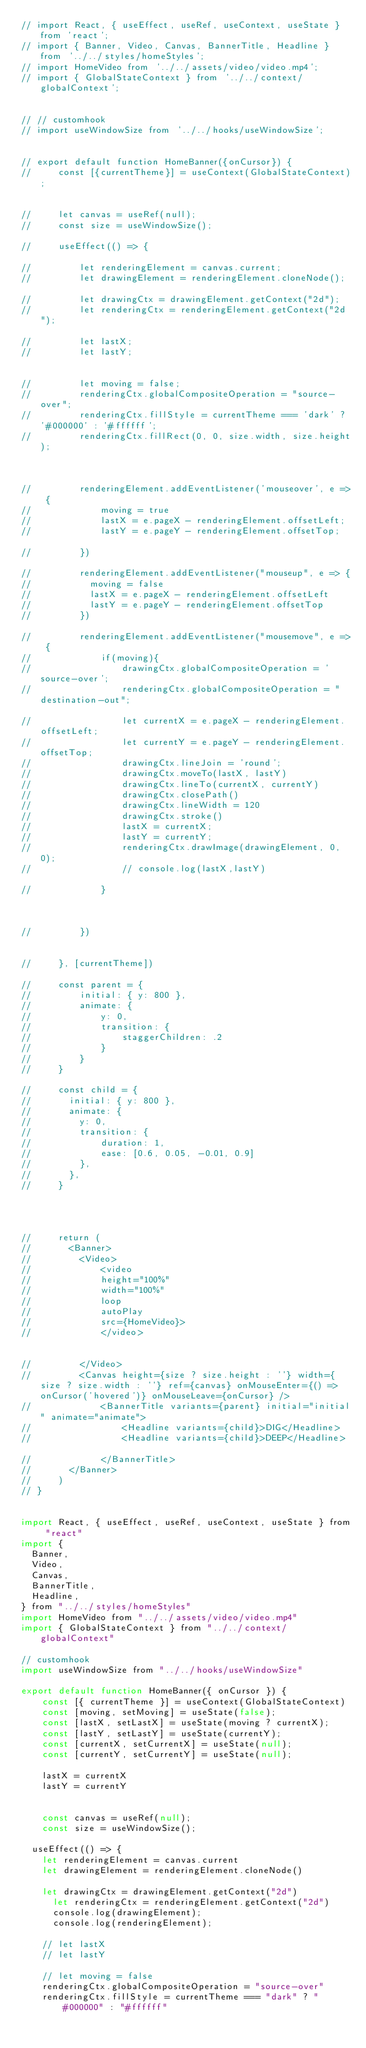<code> <loc_0><loc_0><loc_500><loc_500><_JavaScript_>// import React, { useEffect, useRef, useContext, useState } from 'react';
// import { Banner, Video, Canvas, BannerTitle, Headline } from '../../styles/homeStyles';
// import HomeVideo from '../../assets/video/video.mp4';
// import { GlobalStateContext } from '../../context/globalContext';


// // customhook
// import useWindowSize from '../../hooks/useWindowSize';


// export default function HomeBanner({onCursor}) {
//     const [{currentTheme}] = useContext(GlobalStateContext);
    

//     let canvas = useRef(null);
//     const size = useWindowSize();

//     useEffect(() => {
        
//         let renderingElement = canvas.current;
//         let drawingElement = renderingElement.cloneNode();

//         let drawingCtx = drawingElement.getContext("2d");
//         let renderingCtx = renderingElement.getContext("2d");

//         let lastX;
//         let lastY;
        

//         let moving = false;
//         renderingCtx.globalCompositeOperation = "source-over";
//         renderingCtx.fillStyle = currentTheme === 'dark' ? '#000000' : '#ffffff';
//         renderingCtx.fillRect(0, 0, size.width, size.height);



//         renderingElement.addEventListener('mouseover', e => {
//             moving = true
//             lastX = e.pageX - renderingElement.offsetLeft;
//             lastY = e.pageY - renderingElement.offsetTop;

//         })

//         renderingElement.addEventListener("mouseup", e => {
//           moving = false
//           lastX = e.pageX - renderingElement.offsetLeft
//           lastY = e.pageY - renderingElement.offsetTop
//         })
 
//         renderingElement.addEventListener("mousemove", e => {
//             if(moving){
//                 drawingCtx.globalCompositeOperation = 'source-over';
//                 renderingCtx.globalCompositeOperation = "destination-out";

//                 let currentX = e.pageX - renderingElement.offsetLeft;
//                 let currentY = e.pageY - renderingElement.offsetTop;
//                 drawingCtx.lineJoin = 'round';
//                 drawingCtx.moveTo(lastX, lastY)
//                 drawingCtx.lineTo(currentX, currentY)
//                 drawingCtx.closePath()
//                 drawingCtx.lineWidth = 120
//                 drawingCtx.stroke()
//                 lastX = currentX;
//                 lastY = currentY;
//                 renderingCtx.drawImage(drawingElement, 0, 0);
//                 // console.log(lastX,lastY)

//             }



//         })


//     }, [currentTheme])

//     const parent = {
//         initial: { y: 800 },
//         animate: {
//             y: 0,
//             transition: {
//                 staggerChildren: .2
//             }
//         }
//     }

//     const child = {
//       initial: { y: 800 },
//       animate: {
//         y: 0,
//         transition: {
//             duration: 1,
//             ease: [0.6, 0.05, -0.01, 0.9]
//         },
//       },
//     }
    
    


//     return (
//       <Banner>
//         <Video>
//             <video
//             height="100%"
//             width="100%"
//             loop
//             autoPlay
//             src={HomeVideo}>
//             </video>
                
          
//         </Video>
//         <Canvas height={size ? size.height : ''} width={size ? size.width : ''} ref={canvas} onMouseEnter={() => onCursor('hovered')} onMouseLeave={onCursor} />
//             <BannerTitle variants={parent} initial="initial" animate="animate">
//                 <Headline variants={child}>DIG</Headline>
//                 <Headline variants={child}>DEEP</Headline>

//             </BannerTitle>
//       </Banner>
//     )
// }


import React, { useEffect, useRef, useContext, useState } from "react"
import {
  Banner,
  Video,
  Canvas,
  BannerTitle,
  Headline,
} from "../../styles/homeStyles"
import HomeVideo from "../../assets/video/video.mp4"
import { GlobalStateContext } from "../../context/globalContext"

// customhook
import useWindowSize from "../../hooks/useWindowSize"

export default function HomeBanner({ onCursor }) {
    const [{ currentTheme }] = useContext(GlobalStateContext)
    const [moving, setMoving] = useState(false);
    const [lastX, setLastX] = useState(moving ? currentX);
    const [lastY, setLastY] = useState(currentY);
    const [currentX, setCurrentX] = useState(null);
    const [currentY, setCurrentY] = useState(null);

    lastX = currentX
    lastY = currentY


    const canvas = useRef(null);
    const size = useWindowSize();

  useEffect(() => {
    let renderingElement = canvas.current
    let drawingElement = renderingElement.cloneNode()

    let drawingCtx = drawingElement.getContext("2d")
      let renderingCtx = renderingElement.getContext("2d")
      console.log(drawingElement);
      console.log(renderingElement);

    // let lastX
    // let lastY

    // let moving = false
    renderingCtx.globalCompositeOperation = "source-over"
    renderingCtx.fillStyle = currentTheme === "dark" ? "#000000" : "#ffffff"</code> 